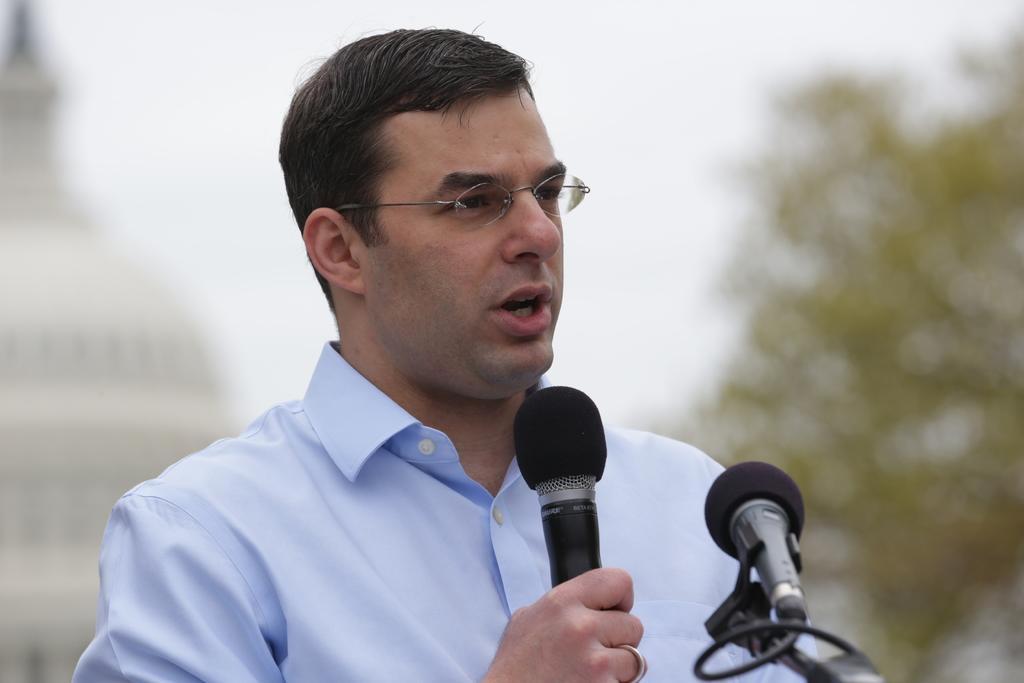In one or two sentences, can you explain what this image depicts? In this picture there is a man holding a mic in his hand. There is also another mic. There is a tree and a building at the background. 